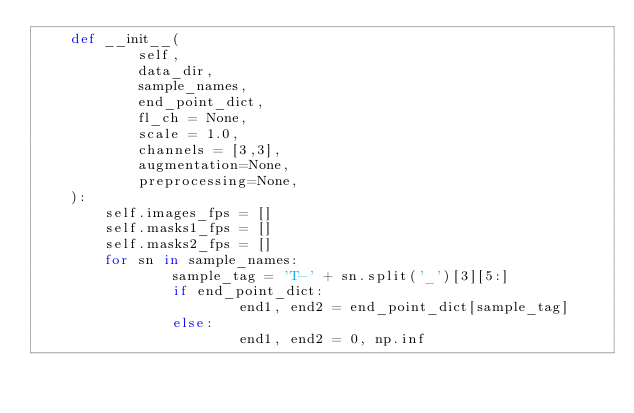Convert code to text. <code><loc_0><loc_0><loc_500><loc_500><_Python_>    def __init__(
            self, 
            data_dir, 
            sample_names,
            end_point_dict,
            fl_ch = None,
            scale = 1.0,
            channels = [3,3],
            augmentation=None, 
            preprocessing=None,
    ):
        self.images_fps = []
        self.masks1_fps = []
        self.masks2_fps = []
        for sn in sample_names:
        		sample_tag = 'T-' + sn.split('_')[3][5:]
        		if end_point_dict:
        				end1, end2 = end_point_dict[sample_tag]
        		else:
        				end1, end2 = 0, np.inf</code> 